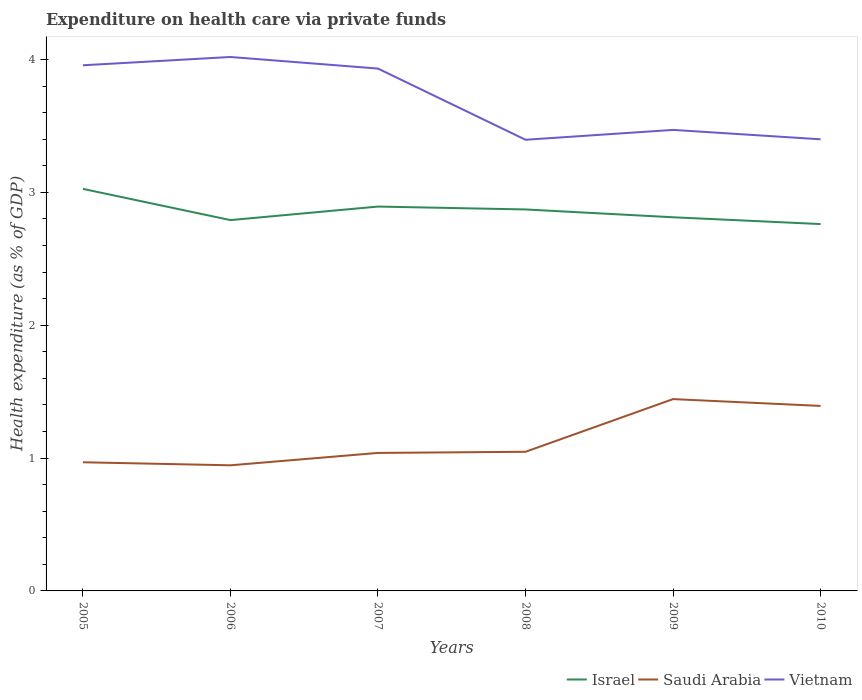Does the line corresponding to Israel intersect with the line corresponding to Saudi Arabia?
Your answer should be compact. No. Across all years, what is the maximum expenditure made on health care in Saudi Arabia?
Make the answer very short. 0.95. What is the total expenditure made on health care in Saudi Arabia in the graph?
Offer a very short reply. -0.01. What is the difference between the highest and the second highest expenditure made on health care in Saudi Arabia?
Your answer should be very brief. 0.5. Is the expenditure made on health care in Israel strictly greater than the expenditure made on health care in Vietnam over the years?
Keep it short and to the point. Yes. How many lines are there?
Make the answer very short. 3. What is the difference between two consecutive major ticks on the Y-axis?
Provide a short and direct response. 1. Are the values on the major ticks of Y-axis written in scientific E-notation?
Provide a succinct answer. No. Does the graph contain grids?
Make the answer very short. No. Where does the legend appear in the graph?
Give a very brief answer. Bottom right. What is the title of the graph?
Your response must be concise. Expenditure on health care via private funds. What is the label or title of the Y-axis?
Ensure brevity in your answer.  Health expenditure (as % of GDP). What is the Health expenditure (as % of GDP) in Israel in 2005?
Your response must be concise. 3.03. What is the Health expenditure (as % of GDP) in Saudi Arabia in 2005?
Offer a terse response. 0.97. What is the Health expenditure (as % of GDP) in Vietnam in 2005?
Provide a succinct answer. 3.96. What is the Health expenditure (as % of GDP) in Israel in 2006?
Offer a terse response. 2.79. What is the Health expenditure (as % of GDP) of Saudi Arabia in 2006?
Ensure brevity in your answer.  0.95. What is the Health expenditure (as % of GDP) of Vietnam in 2006?
Provide a succinct answer. 4.02. What is the Health expenditure (as % of GDP) of Israel in 2007?
Your response must be concise. 2.89. What is the Health expenditure (as % of GDP) of Saudi Arabia in 2007?
Provide a succinct answer. 1.04. What is the Health expenditure (as % of GDP) in Vietnam in 2007?
Give a very brief answer. 3.93. What is the Health expenditure (as % of GDP) of Israel in 2008?
Your answer should be compact. 2.87. What is the Health expenditure (as % of GDP) of Saudi Arabia in 2008?
Offer a very short reply. 1.05. What is the Health expenditure (as % of GDP) of Vietnam in 2008?
Give a very brief answer. 3.4. What is the Health expenditure (as % of GDP) in Israel in 2009?
Ensure brevity in your answer.  2.81. What is the Health expenditure (as % of GDP) in Saudi Arabia in 2009?
Offer a terse response. 1.44. What is the Health expenditure (as % of GDP) of Vietnam in 2009?
Offer a very short reply. 3.47. What is the Health expenditure (as % of GDP) in Israel in 2010?
Provide a short and direct response. 2.76. What is the Health expenditure (as % of GDP) in Saudi Arabia in 2010?
Offer a very short reply. 1.39. What is the Health expenditure (as % of GDP) in Vietnam in 2010?
Your answer should be very brief. 3.4. Across all years, what is the maximum Health expenditure (as % of GDP) in Israel?
Offer a terse response. 3.03. Across all years, what is the maximum Health expenditure (as % of GDP) of Saudi Arabia?
Keep it short and to the point. 1.44. Across all years, what is the maximum Health expenditure (as % of GDP) in Vietnam?
Your answer should be very brief. 4.02. Across all years, what is the minimum Health expenditure (as % of GDP) in Israel?
Give a very brief answer. 2.76. Across all years, what is the minimum Health expenditure (as % of GDP) of Saudi Arabia?
Make the answer very short. 0.95. Across all years, what is the minimum Health expenditure (as % of GDP) of Vietnam?
Ensure brevity in your answer.  3.4. What is the total Health expenditure (as % of GDP) in Israel in the graph?
Keep it short and to the point. 17.16. What is the total Health expenditure (as % of GDP) in Saudi Arabia in the graph?
Give a very brief answer. 6.84. What is the total Health expenditure (as % of GDP) in Vietnam in the graph?
Keep it short and to the point. 22.18. What is the difference between the Health expenditure (as % of GDP) in Israel in 2005 and that in 2006?
Ensure brevity in your answer.  0.23. What is the difference between the Health expenditure (as % of GDP) in Saudi Arabia in 2005 and that in 2006?
Provide a succinct answer. 0.02. What is the difference between the Health expenditure (as % of GDP) of Vietnam in 2005 and that in 2006?
Your response must be concise. -0.06. What is the difference between the Health expenditure (as % of GDP) in Israel in 2005 and that in 2007?
Ensure brevity in your answer.  0.13. What is the difference between the Health expenditure (as % of GDP) of Saudi Arabia in 2005 and that in 2007?
Keep it short and to the point. -0.07. What is the difference between the Health expenditure (as % of GDP) of Vietnam in 2005 and that in 2007?
Provide a short and direct response. 0.02. What is the difference between the Health expenditure (as % of GDP) in Israel in 2005 and that in 2008?
Ensure brevity in your answer.  0.15. What is the difference between the Health expenditure (as % of GDP) in Saudi Arabia in 2005 and that in 2008?
Make the answer very short. -0.08. What is the difference between the Health expenditure (as % of GDP) of Vietnam in 2005 and that in 2008?
Keep it short and to the point. 0.56. What is the difference between the Health expenditure (as % of GDP) in Israel in 2005 and that in 2009?
Your answer should be compact. 0.21. What is the difference between the Health expenditure (as % of GDP) in Saudi Arabia in 2005 and that in 2009?
Provide a short and direct response. -0.48. What is the difference between the Health expenditure (as % of GDP) in Vietnam in 2005 and that in 2009?
Keep it short and to the point. 0.49. What is the difference between the Health expenditure (as % of GDP) of Israel in 2005 and that in 2010?
Give a very brief answer. 0.26. What is the difference between the Health expenditure (as % of GDP) of Saudi Arabia in 2005 and that in 2010?
Your response must be concise. -0.42. What is the difference between the Health expenditure (as % of GDP) of Vietnam in 2005 and that in 2010?
Offer a terse response. 0.56. What is the difference between the Health expenditure (as % of GDP) in Israel in 2006 and that in 2007?
Keep it short and to the point. -0.1. What is the difference between the Health expenditure (as % of GDP) in Saudi Arabia in 2006 and that in 2007?
Offer a very short reply. -0.09. What is the difference between the Health expenditure (as % of GDP) in Vietnam in 2006 and that in 2007?
Your response must be concise. 0.09. What is the difference between the Health expenditure (as % of GDP) in Israel in 2006 and that in 2008?
Offer a very short reply. -0.08. What is the difference between the Health expenditure (as % of GDP) in Saudi Arabia in 2006 and that in 2008?
Give a very brief answer. -0.1. What is the difference between the Health expenditure (as % of GDP) in Vietnam in 2006 and that in 2008?
Offer a terse response. 0.62. What is the difference between the Health expenditure (as % of GDP) of Israel in 2006 and that in 2009?
Provide a short and direct response. -0.02. What is the difference between the Health expenditure (as % of GDP) of Saudi Arabia in 2006 and that in 2009?
Your response must be concise. -0.5. What is the difference between the Health expenditure (as % of GDP) of Vietnam in 2006 and that in 2009?
Provide a succinct answer. 0.55. What is the difference between the Health expenditure (as % of GDP) in Israel in 2006 and that in 2010?
Give a very brief answer. 0.03. What is the difference between the Health expenditure (as % of GDP) in Saudi Arabia in 2006 and that in 2010?
Your answer should be compact. -0.45. What is the difference between the Health expenditure (as % of GDP) of Vietnam in 2006 and that in 2010?
Provide a short and direct response. 0.62. What is the difference between the Health expenditure (as % of GDP) in Israel in 2007 and that in 2008?
Keep it short and to the point. 0.02. What is the difference between the Health expenditure (as % of GDP) of Saudi Arabia in 2007 and that in 2008?
Provide a succinct answer. -0.01. What is the difference between the Health expenditure (as % of GDP) in Vietnam in 2007 and that in 2008?
Ensure brevity in your answer.  0.54. What is the difference between the Health expenditure (as % of GDP) of Israel in 2007 and that in 2009?
Ensure brevity in your answer.  0.08. What is the difference between the Health expenditure (as % of GDP) of Saudi Arabia in 2007 and that in 2009?
Keep it short and to the point. -0.41. What is the difference between the Health expenditure (as % of GDP) in Vietnam in 2007 and that in 2009?
Offer a terse response. 0.46. What is the difference between the Health expenditure (as % of GDP) in Israel in 2007 and that in 2010?
Your response must be concise. 0.13. What is the difference between the Health expenditure (as % of GDP) in Saudi Arabia in 2007 and that in 2010?
Your response must be concise. -0.35. What is the difference between the Health expenditure (as % of GDP) in Vietnam in 2007 and that in 2010?
Your response must be concise. 0.53. What is the difference between the Health expenditure (as % of GDP) of Israel in 2008 and that in 2009?
Offer a terse response. 0.06. What is the difference between the Health expenditure (as % of GDP) in Saudi Arabia in 2008 and that in 2009?
Keep it short and to the point. -0.4. What is the difference between the Health expenditure (as % of GDP) of Vietnam in 2008 and that in 2009?
Your answer should be very brief. -0.07. What is the difference between the Health expenditure (as % of GDP) in Israel in 2008 and that in 2010?
Your answer should be compact. 0.11. What is the difference between the Health expenditure (as % of GDP) in Saudi Arabia in 2008 and that in 2010?
Your answer should be very brief. -0.35. What is the difference between the Health expenditure (as % of GDP) in Vietnam in 2008 and that in 2010?
Provide a short and direct response. -0. What is the difference between the Health expenditure (as % of GDP) of Israel in 2009 and that in 2010?
Offer a terse response. 0.05. What is the difference between the Health expenditure (as % of GDP) in Saudi Arabia in 2009 and that in 2010?
Ensure brevity in your answer.  0.05. What is the difference between the Health expenditure (as % of GDP) in Vietnam in 2009 and that in 2010?
Your answer should be compact. 0.07. What is the difference between the Health expenditure (as % of GDP) in Israel in 2005 and the Health expenditure (as % of GDP) in Saudi Arabia in 2006?
Give a very brief answer. 2.08. What is the difference between the Health expenditure (as % of GDP) in Israel in 2005 and the Health expenditure (as % of GDP) in Vietnam in 2006?
Make the answer very short. -0.99. What is the difference between the Health expenditure (as % of GDP) of Saudi Arabia in 2005 and the Health expenditure (as % of GDP) of Vietnam in 2006?
Keep it short and to the point. -3.05. What is the difference between the Health expenditure (as % of GDP) of Israel in 2005 and the Health expenditure (as % of GDP) of Saudi Arabia in 2007?
Your answer should be compact. 1.99. What is the difference between the Health expenditure (as % of GDP) of Israel in 2005 and the Health expenditure (as % of GDP) of Vietnam in 2007?
Provide a short and direct response. -0.91. What is the difference between the Health expenditure (as % of GDP) of Saudi Arabia in 2005 and the Health expenditure (as % of GDP) of Vietnam in 2007?
Offer a very short reply. -2.96. What is the difference between the Health expenditure (as % of GDP) in Israel in 2005 and the Health expenditure (as % of GDP) in Saudi Arabia in 2008?
Your response must be concise. 1.98. What is the difference between the Health expenditure (as % of GDP) in Israel in 2005 and the Health expenditure (as % of GDP) in Vietnam in 2008?
Provide a succinct answer. -0.37. What is the difference between the Health expenditure (as % of GDP) of Saudi Arabia in 2005 and the Health expenditure (as % of GDP) of Vietnam in 2008?
Ensure brevity in your answer.  -2.43. What is the difference between the Health expenditure (as % of GDP) of Israel in 2005 and the Health expenditure (as % of GDP) of Saudi Arabia in 2009?
Offer a very short reply. 1.58. What is the difference between the Health expenditure (as % of GDP) in Israel in 2005 and the Health expenditure (as % of GDP) in Vietnam in 2009?
Ensure brevity in your answer.  -0.44. What is the difference between the Health expenditure (as % of GDP) of Saudi Arabia in 2005 and the Health expenditure (as % of GDP) of Vietnam in 2009?
Your response must be concise. -2.5. What is the difference between the Health expenditure (as % of GDP) in Israel in 2005 and the Health expenditure (as % of GDP) in Saudi Arabia in 2010?
Ensure brevity in your answer.  1.63. What is the difference between the Health expenditure (as % of GDP) of Israel in 2005 and the Health expenditure (as % of GDP) of Vietnam in 2010?
Keep it short and to the point. -0.37. What is the difference between the Health expenditure (as % of GDP) in Saudi Arabia in 2005 and the Health expenditure (as % of GDP) in Vietnam in 2010?
Make the answer very short. -2.43. What is the difference between the Health expenditure (as % of GDP) in Israel in 2006 and the Health expenditure (as % of GDP) in Saudi Arabia in 2007?
Provide a succinct answer. 1.75. What is the difference between the Health expenditure (as % of GDP) in Israel in 2006 and the Health expenditure (as % of GDP) in Vietnam in 2007?
Provide a succinct answer. -1.14. What is the difference between the Health expenditure (as % of GDP) of Saudi Arabia in 2006 and the Health expenditure (as % of GDP) of Vietnam in 2007?
Your answer should be very brief. -2.99. What is the difference between the Health expenditure (as % of GDP) in Israel in 2006 and the Health expenditure (as % of GDP) in Saudi Arabia in 2008?
Ensure brevity in your answer.  1.74. What is the difference between the Health expenditure (as % of GDP) in Israel in 2006 and the Health expenditure (as % of GDP) in Vietnam in 2008?
Make the answer very short. -0.6. What is the difference between the Health expenditure (as % of GDP) in Saudi Arabia in 2006 and the Health expenditure (as % of GDP) in Vietnam in 2008?
Ensure brevity in your answer.  -2.45. What is the difference between the Health expenditure (as % of GDP) of Israel in 2006 and the Health expenditure (as % of GDP) of Saudi Arabia in 2009?
Your response must be concise. 1.35. What is the difference between the Health expenditure (as % of GDP) of Israel in 2006 and the Health expenditure (as % of GDP) of Vietnam in 2009?
Your response must be concise. -0.68. What is the difference between the Health expenditure (as % of GDP) in Saudi Arabia in 2006 and the Health expenditure (as % of GDP) in Vietnam in 2009?
Your answer should be very brief. -2.52. What is the difference between the Health expenditure (as % of GDP) of Israel in 2006 and the Health expenditure (as % of GDP) of Saudi Arabia in 2010?
Keep it short and to the point. 1.4. What is the difference between the Health expenditure (as % of GDP) of Israel in 2006 and the Health expenditure (as % of GDP) of Vietnam in 2010?
Your answer should be compact. -0.61. What is the difference between the Health expenditure (as % of GDP) in Saudi Arabia in 2006 and the Health expenditure (as % of GDP) in Vietnam in 2010?
Your answer should be very brief. -2.45. What is the difference between the Health expenditure (as % of GDP) in Israel in 2007 and the Health expenditure (as % of GDP) in Saudi Arabia in 2008?
Offer a very short reply. 1.85. What is the difference between the Health expenditure (as % of GDP) of Israel in 2007 and the Health expenditure (as % of GDP) of Vietnam in 2008?
Offer a terse response. -0.5. What is the difference between the Health expenditure (as % of GDP) of Saudi Arabia in 2007 and the Health expenditure (as % of GDP) of Vietnam in 2008?
Provide a short and direct response. -2.36. What is the difference between the Health expenditure (as % of GDP) in Israel in 2007 and the Health expenditure (as % of GDP) in Saudi Arabia in 2009?
Your response must be concise. 1.45. What is the difference between the Health expenditure (as % of GDP) in Israel in 2007 and the Health expenditure (as % of GDP) in Vietnam in 2009?
Ensure brevity in your answer.  -0.58. What is the difference between the Health expenditure (as % of GDP) in Saudi Arabia in 2007 and the Health expenditure (as % of GDP) in Vietnam in 2009?
Make the answer very short. -2.43. What is the difference between the Health expenditure (as % of GDP) of Israel in 2007 and the Health expenditure (as % of GDP) of Saudi Arabia in 2010?
Give a very brief answer. 1.5. What is the difference between the Health expenditure (as % of GDP) in Israel in 2007 and the Health expenditure (as % of GDP) in Vietnam in 2010?
Provide a succinct answer. -0.51. What is the difference between the Health expenditure (as % of GDP) in Saudi Arabia in 2007 and the Health expenditure (as % of GDP) in Vietnam in 2010?
Offer a terse response. -2.36. What is the difference between the Health expenditure (as % of GDP) in Israel in 2008 and the Health expenditure (as % of GDP) in Saudi Arabia in 2009?
Provide a succinct answer. 1.43. What is the difference between the Health expenditure (as % of GDP) of Israel in 2008 and the Health expenditure (as % of GDP) of Vietnam in 2009?
Give a very brief answer. -0.6. What is the difference between the Health expenditure (as % of GDP) in Saudi Arabia in 2008 and the Health expenditure (as % of GDP) in Vietnam in 2009?
Ensure brevity in your answer.  -2.42. What is the difference between the Health expenditure (as % of GDP) in Israel in 2008 and the Health expenditure (as % of GDP) in Saudi Arabia in 2010?
Offer a very short reply. 1.48. What is the difference between the Health expenditure (as % of GDP) in Israel in 2008 and the Health expenditure (as % of GDP) in Vietnam in 2010?
Ensure brevity in your answer.  -0.53. What is the difference between the Health expenditure (as % of GDP) in Saudi Arabia in 2008 and the Health expenditure (as % of GDP) in Vietnam in 2010?
Offer a very short reply. -2.35. What is the difference between the Health expenditure (as % of GDP) of Israel in 2009 and the Health expenditure (as % of GDP) of Saudi Arabia in 2010?
Offer a terse response. 1.42. What is the difference between the Health expenditure (as % of GDP) in Israel in 2009 and the Health expenditure (as % of GDP) in Vietnam in 2010?
Ensure brevity in your answer.  -0.59. What is the difference between the Health expenditure (as % of GDP) of Saudi Arabia in 2009 and the Health expenditure (as % of GDP) of Vietnam in 2010?
Ensure brevity in your answer.  -1.96. What is the average Health expenditure (as % of GDP) in Israel per year?
Keep it short and to the point. 2.86. What is the average Health expenditure (as % of GDP) in Saudi Arabia per year?
Your response must be concise. 1.14. What is the average Health expenditure (as % of GDP) of Vietnam per year?
Keep it short and to the point. 3.7. In the year 2005, what is the difference between the Health expenditure (as % of GDP) in Israel and Health expenditure (as % of GDP) in Saudi Arabia?
Your answer should be compact. 2.06. In the year 2005, what is the difference between the Health expenditure (as % of GDP) in Israel and Health expenditure (as % of GDP) in Vietnam?
Give a very brief answer. -0.93. In the year 2005, what is the difference between the Health expenditure (as % of GDP) of Saudi Arabia and Health expenditure (as % of GDP) of Vietnam?
Give a very brief answer. -2.99. In the year 2006, what is the difference between the Health expenditure (as % of GDP) in Israel and Health expenditure (as % of GDP) in Saudi Arabia?
Your response must be concise. 1.85. In the year 2006, what is the difference between the Health expenditure (as % of GDP) of Israel and Health expenditure (as % of GDP) of Vietnam?
Your answer should be compact. -1.23. In the year 2006, what is the difference between the Health expenditure (as % of GDP) in Saudi Arabia and Health expenditure (as % of GDP) in Vietnam?
Your response must be concise. -3.07. In the year 2007, what is the difference between the Health expenditure (as % of GDP) of Israel and Health expenditure (as % of GDP) of Saudi Arabia?
Offer a terse response. 1.85. In the year 2007, what is the difference between the Health expenditure (as % of GDP) in Israel and Health expenditure (as % of GDP) in Vietnam?
Keep it short and to the point. -1.04. In the year 2007, what is the difference between the Health expenditure (as % of GDP) in Saudi Arabia and Health expenditure (as % of GDP) in Vietnam?
Your answer should be compact. -2.89. In the year 2008, what is the difference between the Health expenditure (as % of GDP) in Israel and Health expenditure (as % of GDP) in Saudi Arabia?
Provide a short and direct response. 1.82. In the year 2008, what is the difference between the Health expenditure (as % of GDP) of Israel and Health expenditure (as % of GDP) of Vietnam?
Your answer should be very brief. -0.52. In the year 2008, what is the difference between the Health expenditure (as % of GDP) of Saudi Arabia and Health expenditure (as % of GDP) of Vietnam?
Your answer should be compact. -2.35. In the year 2009, what is the difference between the Health expenditure (as % of GDP) of Israel and Health expenditure (as % of GDP) of Saudi Arabia?
Provide a succinct answer. 1.37. In the year 2009, what is the difference between the Health expenditure (as % of GDP) in Israel and Health expenditure (as % of GDP) in Vietnam?
Your response must be concise. -0.66. In the year 2009, what is the difference between the Health expenditure (as % of GDP) in Saudi Arabia and Health expenditure (as % of GDP) in Vietnam?
Provide a succinct answer. -2.03. In the year 2010, what is the difference between the Health expenditure (as % of GDP) in Israel and Health expenditure (as % of GDP) in Saudi Arabia?
Your response must be concise. 1.37. In the year 2010, what is the difference between the Health expenditure (as % of GDP) of Israel and Health expenditure (as % of GDP) of Vietnam?
Ensure brevity in your answer.  -0.64. In the year 2010, what is the difference between the Health expenditure (as % of GDP) of Saudi Arabia and Health expenditure (as % of GDP) of Vietnam?
Make the answer very short. -2.01. What is the ratio of the Health expenditure (as % of GDP) of Israel in 2005 to that in 2006?
Your answer should be very brief. 1.08. What is the ratio of the Health expenditure (as % of GDP) in Saudi Arabia in 2005 to that in 2006?
Your answer should be very brief. 1.02. What is the ratio of the Health expenditure (as % of GDP) of Vietnam in 2005 to that in 2006?
Provide a succinct answer. 0.98. What is the ratio of the Health expenditure (as % of GDP) of Israel in 2005 to that in 2007?
Provide a succinct answer. 1.05. What is the ratio of the Health expenditure (as % of GDP) of Saudi Arabia in 2005 to that in 2007?
Your answer should be very brief. 0.93. What is the ratio of the Health expenditure (as % of GDP) in Israel in 2005 to that in 2008?
Provide a short and direct response. 1.05. What is the ratio of the Health expenditure (as % of GDP) of Saudi Arabia in 2005 to that in 2008?
Offer a terse response. 0.92. What is the ratio of the Health expenditure (as % of GDP) of Vietnam in 2005 to that in 2008?
Provide a succinct answer. 1.17. What is the ratio of the Health expenditure (as % of GDP) in Israel in 2005 to that in 2009?
Your answer should be compact. 1.08. What is the ratio of the Health expenditure (as % of GDP) in Saudi Arabia in 2005 to that in 2009?
Give a very brief answer. 0.67. What is the ratio of the Health expenditure (as % of GDP) in Vietnam in 2005 to that in 2009?
Your answer should be very brief. 1.14. What is the ratio of the Health expenditure (as % of GDP) of Israel in 2005 to that in 2010?
Your response must be concise. 1.1. What is the ratio of the Health expenditure (as % of GDP) in Saudi Arabia in 2005 to that in 2010?
Give a very brief answer. 0.7. What is the ratio of the Health expenditure (as % of GDP) in Vietnam in 2005 to that in 2010?
Your answer should be compact. 1.16. What is the ratio of the Health expenditure (as % of GDP) of Israel in 2006 to that in 2007?
Offer a terse response. 0.96. What is the ratio of the Health expenditure (as % of GDP) in Saudi Arabia in 2006 to that in 2007?
Offer a terse response. 0.91. What is the ratio of the Health expenditure (as % of GDP) of Vietnam in 2006 to that in 2007?
Your response must be concise. 1.02. What is the ratio of the Health expenditure (as % of GDP) in Israel in 2006 to that in 2008?
Give a very brief answer. 0.97. What is the ratio of the Health expenditure (as % of GDP) in Saudi Arabia in 2006 to that in 2008?
Offer a very short reply. 0.9. What is the ratio of the Health expenditure (as % of GDP) in Vietnam in 2006 to that in 2008?
Provide a short and direct response. 1.18. What is the ratio of the Health expenditure (as % of GDP) in Saudi Arabia in 2006 to that in 2009?
Offer a very short reply. 0.65. What is the ratio of the Health expenditure (as % of GDP) in Vietnam in 2006 to that in 2009?
Provide a succinct answer. 1.16. What is the ratio of the Health expenditure (as % of GDP) in Israel in 2006 to that in 2010?
Provide a succinct answer. 1.01. What is the ratio of the Health expenditure (as % of GDP) of Saudi Arabia in 2006 to that in 2010?
Provide a short and direct response. 0.68. What is the ratio of the Health expenditure (as % of GDP) of Vietnam in 2006 to that in 2010?
Your response must be concise. 1.18. What is the ratio of the Health expenditure (as % of GDP) in Israel in 2007 to that in 2008?
Your response must be concise. 1.01. What is the ratio of the Health expenditure (as % of GDP) of Vietnam in 2007 to that in 2008?
Keep it short and to the point. 1.16. What is the ratio of the Health expenditure (as % of GDP) of Israel in 2007 to that in 2009?
Your answer should be very brief. 1.03. What is the ratio of the Health expenditure (as % of GDP) in Saudi Arabia in 2007 to that in 2009?
Your answer should be very brief. 0.72. What is the ratio of the Health expenditure (as % of GDP) in Vietnam in 2007 to that in 2009?
Your answer should be very brief. 1.13. What is the ratio of the Health expenditure (as % of GDP) of Israel in 2007 to that in 2010?
Keep it short and to the point. 1.05. What is the ratio of the Health expenditure (as % of GDP) of Saudi Arabia in 2007 to that in 2010?
Give a very brief answer. 0.75. What is the ratio of the Health expenditure (as % of GDP) of Vietnam in 2007 to that in 2010?
Give a very brief answer. 1.16. What is the ratio of the Health expenditure (as % of GDP) of Israel in 2008 to that in 2009?
Offer a terse response. 1.02. What is the ratio of the Health expenditure (as % of GDP) of Saudi Arabia in 2008 to that in 2009?
Give a very brief answer. 0.73. What is the ratio of the Health expenditure (as % of GDP) of Vietnam in 2008 to that in 2009?
Keep it short and to the point. 0.98. What is the ratio of the Health expenditure (as % of GDP) of Israel in 2008 to that in 2010?
Your answer should be compact. 1.04. What is the ratio of the Health expenditure (as % of GDP) in Saudi Arabia in 2008 to that in 2010?
Ensure brevity in your answer.  0.75. What is the ratio of the Health expenditure (as % of GDP) in Vietnam in 2008 to that in 2010?
Make the answer very short. 1. What is the ratio of the Health expenditure (as % of GDP) of Israel in 2009 to that in 2010?
Ensure brevity in your answer.  1.02. What is the ratio of the Health expenditure (as % of GDP) of Saudi Arabia in 2009 to that in 2010?
Ensure brevity in your answer.  1.04. What is the ratio of the Health expenditure (as % of GDP) in Vietnam in 2009 to that in 2010?
Ensure brevity in your answer.  1.02. What is the difference between the highest and the second highest Health expenditure (as % of GDP) of Israel?
Your answer should be compact. 0.13. What is the difference between the highest and the second highest Health expenditure (as % of GDP) in Saudi Arabia?
Your answer should be very brief. 0.05. What is the difference between the highest and the second highest Health expenditure (as % of GDP) of Vietnam?
Provide a succinct answer. 0.06. What is the difference between the highest and the lowest Health expenditure (as % of GDP) of Israel?
Your response must be concise. 0.26. What is the difference between the highest and the lowest Health expenditure (as % of GDP) in Saudi Arabia?
Provide a succinct answer. 0.5. What is the difference between the highest and the lowest Health expenditure (as % of GDP) of Vietnam?
Provide a short and direct response. 0.62. 